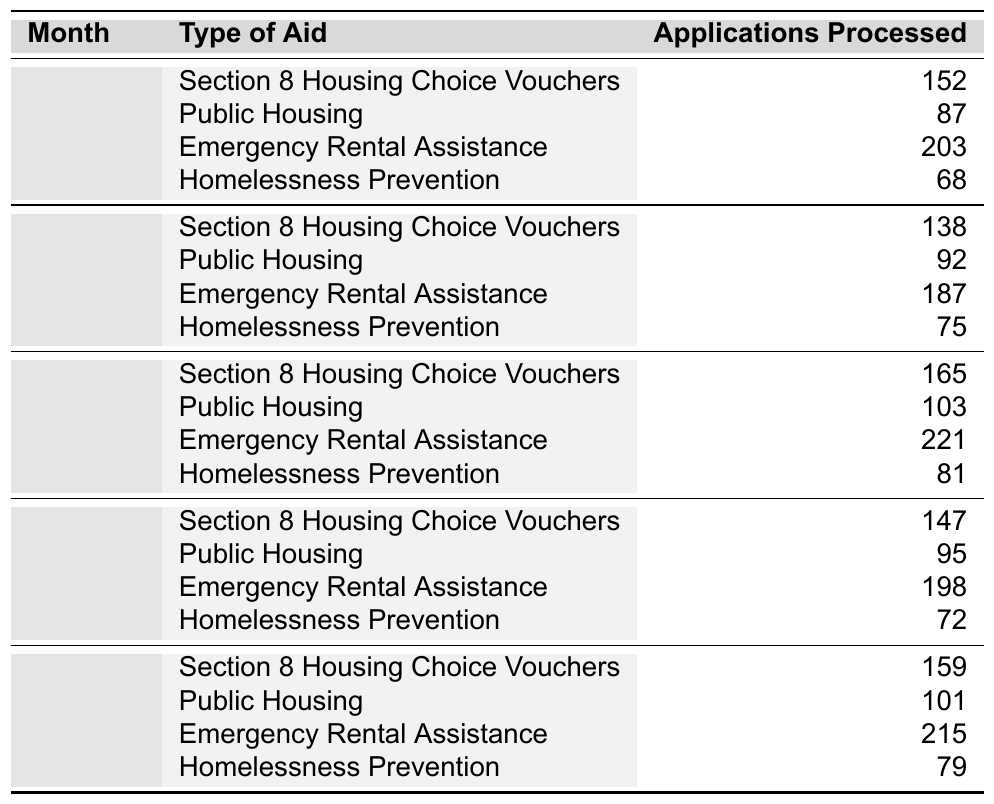What type of aid had the highest number of applications processed in January? In January, the data shows that "Emergency Rental Assistance" had the highest number of applications processed at 203, compared to other types of aid.
Answer: Emergency Rental Assistance How many applications were processed for Public Housing in February? In February, the table indicates that 92 applications were processed for Public Housing.
Answer: 92 What was the total number of applications processed for all types of aid in March? To find the total for March, add the applications: 165 (Section 8) + 103 (Public Housing) + 221 (Emergency Rental Assistance) + 81 (Homelessness Prevention) = 570.
Answer: 570 In which month was the number of applications for Section 8 Housing Choice Vouchers the lowest? Reviewing the data, the applications for Section 8 Housing Choice Vouchers were lowest in February, with 138 applications processed.
Answer: February What is the average number of applications processed for Homelessness Prevention across the five months? To find the average, first sum the applications: 68 + 75 + 81 + 72 + 79 = 375. Then divide by the number of months: 375 / 5 = 75.
Answer: 75 Did the number of applications processed for Emergency Rental Assistance increase from February to March? Comparing the two months, February had 187 applications and March had 221 applications, indicating an increase.
Answer: Yes Which type of aid had the highest overall applications processed across the five months? By summing the applications for each aid type: Section 8: 152 + 138 + 165 + 147 + 159 = 761, Public Housing: 87 + 92 + 103 + 95 + 101 = 478, Emergency Rental Assistance: 203 + 187 + 221 + 198 + 215 = 1024, Homelessness Prevention: 68 + 75 + 81 + 72 + 79 = 375. The highest is Emergency Rental Assistance with 1024 applications.
Answer: Emergency Rental Assistance What was the difference in the number of applications processed for Section 8 Housing Choice Vouchers between January and May? In January, 152 applications were processed, and in May, 159 applications were processed. The difference is 159 - 152 = 7.
Answer: 7 How many applications for all types of aid were processed in April compared to January? In April, the total is 147 (Section 8) + 95 (Public Housing) + 198 (Emergency Rental Assistance) + 72 (Homelessness Prevention) = 512. In January, the total is 152 + 87 + 203 + 68 = 510. Comparing them shows April had 2 more applications than January.
Answer: April had 2 more applications than January 